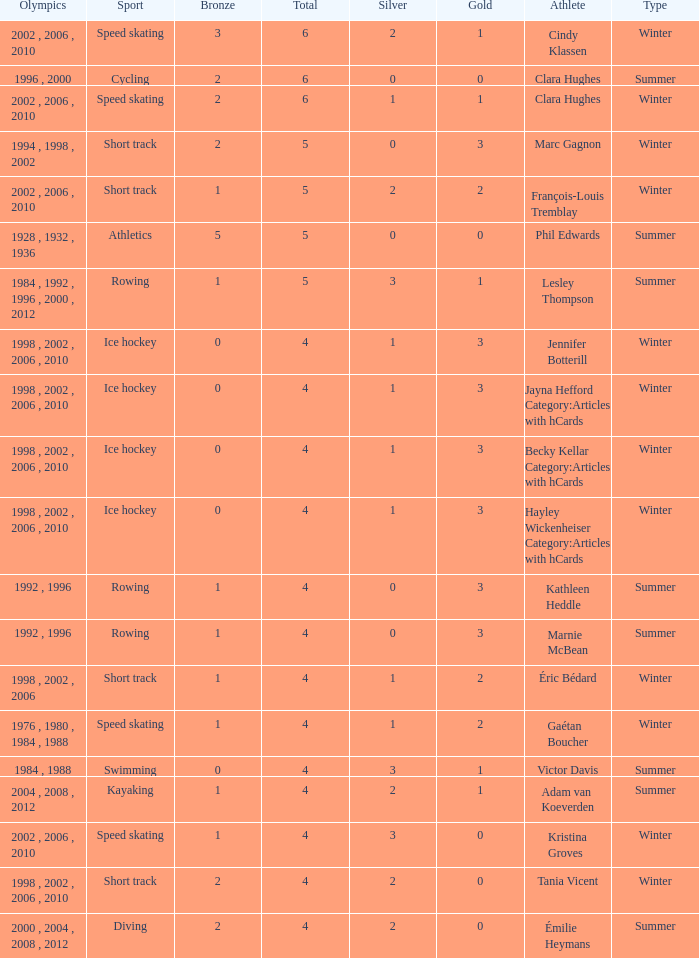What is the highest total medals winter athlete Clara Hughes has? 6.0. 